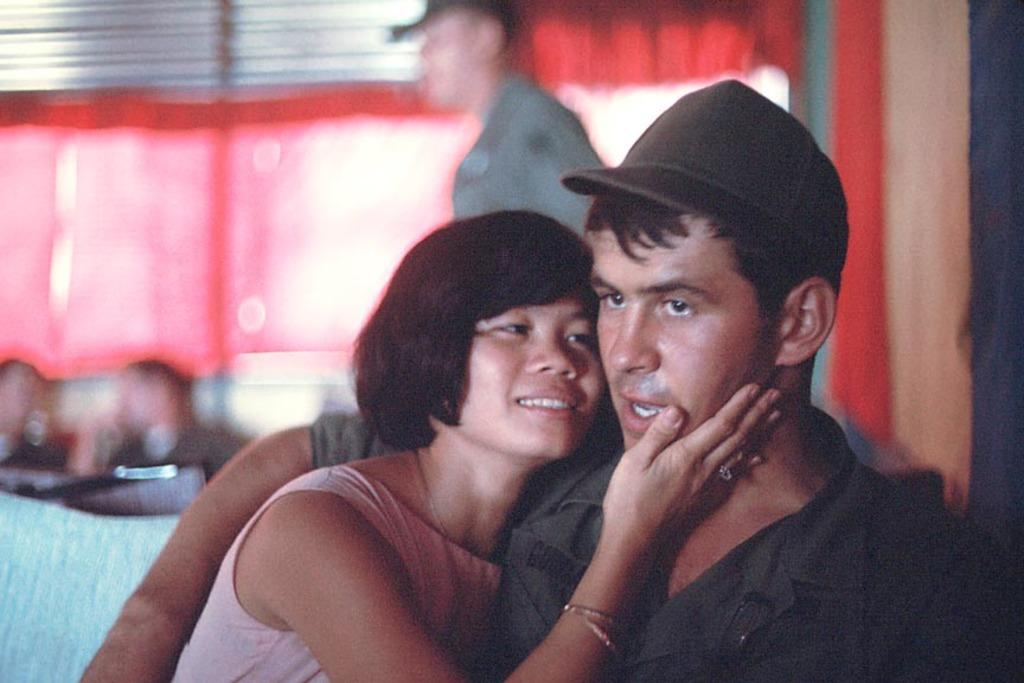How many people are present in the image? There are two people, a man and a woman, present in the image. What are the man and woman doing in the image? The man and woman are holding each other in the image. Can you describe the man's attire in the image? The man is wearing a cap in the image. What can be seen in the background of the image? The background of the image is blurred, and there are people visible in the background. What type of comb can be seen in the man's hair in the image? There is no comb visible in the man's hair in the image. Can you tell me how many dinosaurs are present in the image? There are no dinosaurs present in the image. 